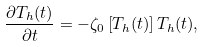<formula> <loc_0><loc_0><loc_500><loc_500>\frac { \partial T _ { h } ( t ) } { \partial t } = - \zeta _ { 0 } \left [ T _ { h } ( t ) \right ] T _ { h } ( t ) ,</formula> 